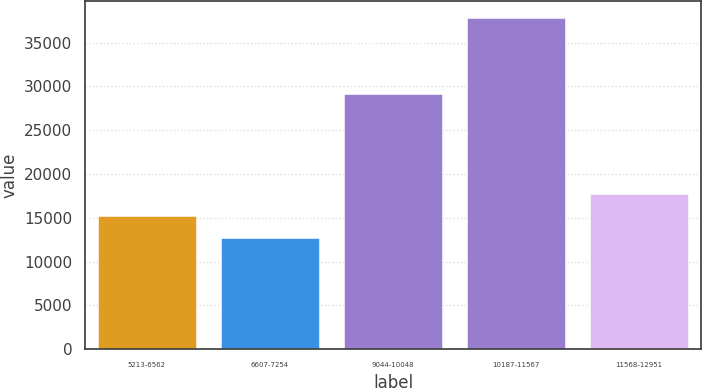Convert chart. <chart><loc_0><loc_0><loc_500><loc_500><bar_chart><fcel>5213-6562<fcel>6607-7254<fcel>9044-10048<fcel>10187-11567<fcel>11568-12951<nl><fcel>15226.7<fcel>12710<fcel>29162<fcel>37877<fcel>17743.4<nl></chart> 